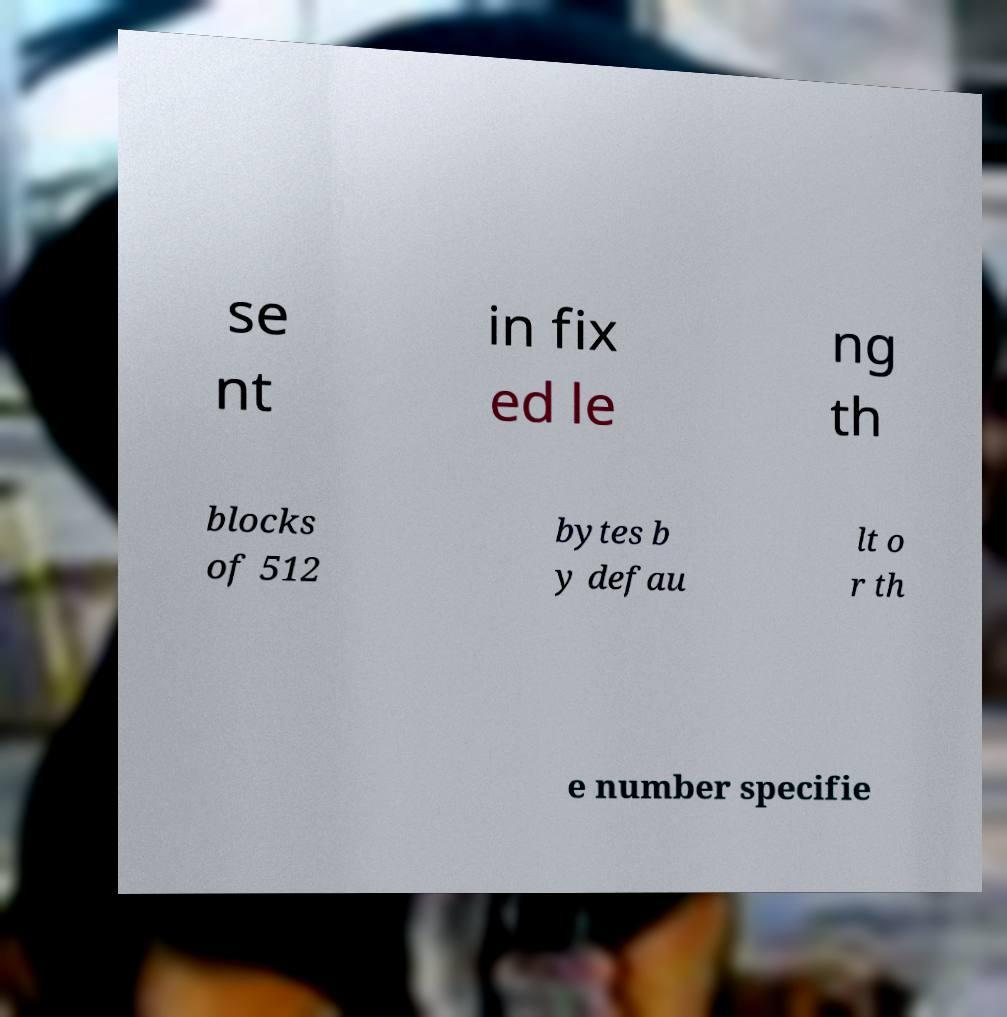For documentation purposes, I need the text within this image transcribed. Could you provide that? se nt in fix ed le ng th blocks of 512 bytes b y defau lt o r th e number specifie 